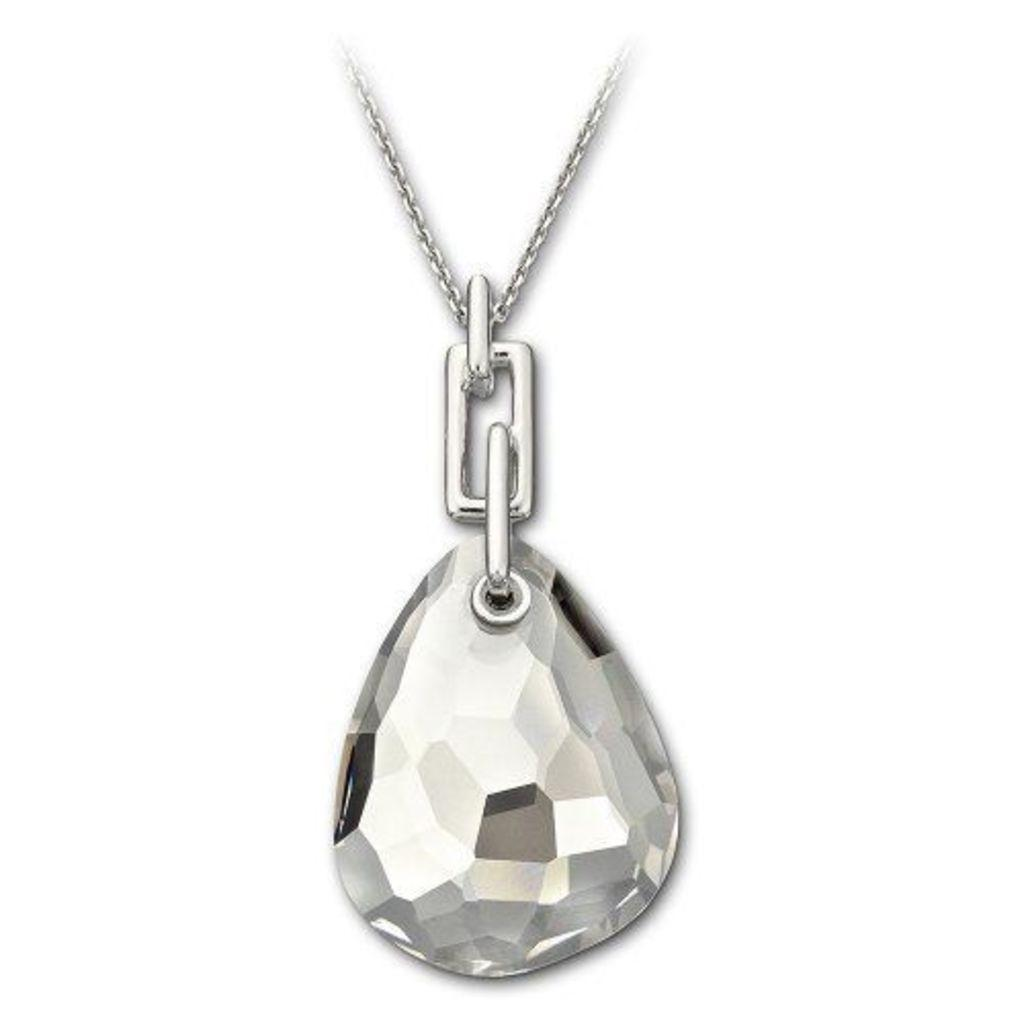What is the main object in the image? There is a locket in the image. How is the locket shaped? The locket is in the shape of an almond. Is the locket connected to anything else in the image? Yes, the locket is attached to a chain. Is there a volcano erupting in the background of the image? There is no mention of a volcano or any background in the provided facts, so we cannot determine if there is a volcano in the image. 